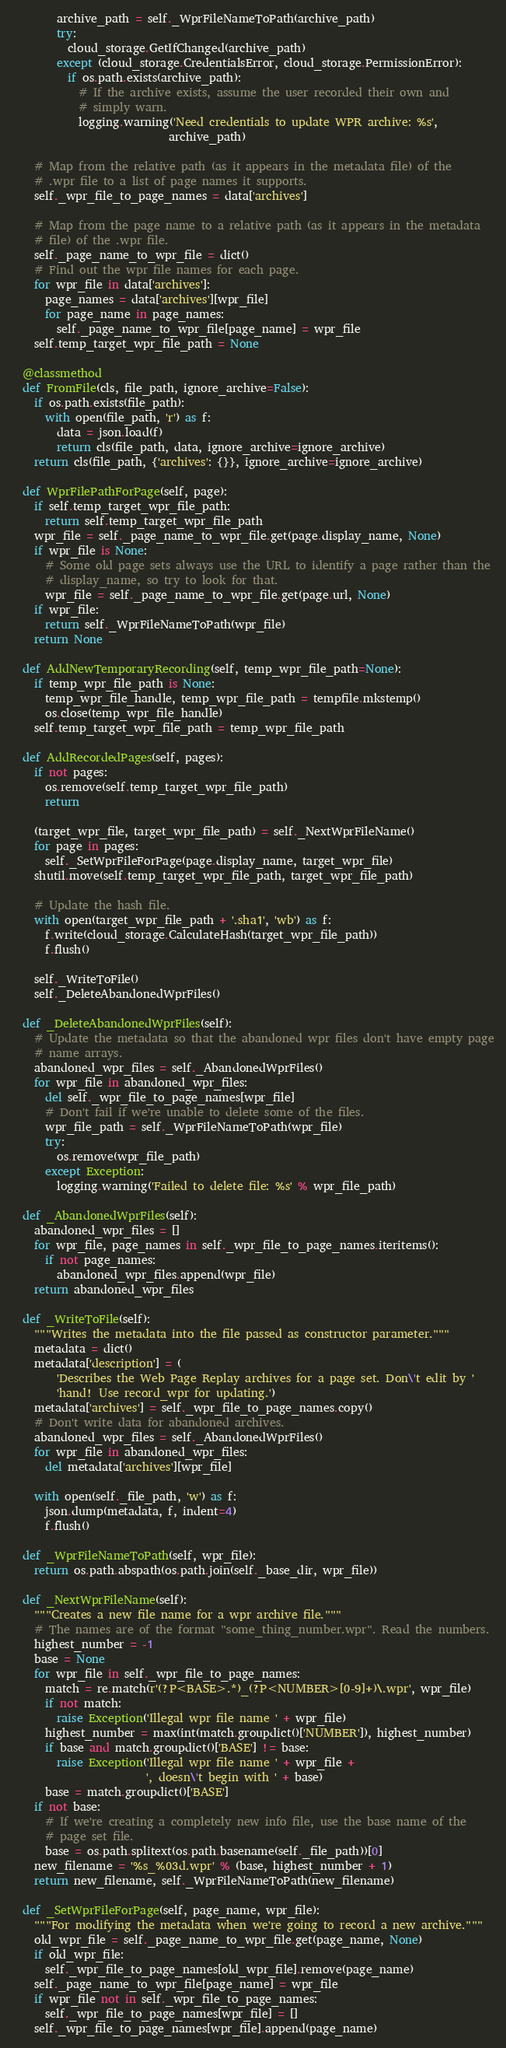<code> <loc_0><loc_0><loc_500><loc_500><_Python_>        archive_path = self._WprFileNameToPath(archive_path)
        try:
          cloud_storage.GetIfChanged(archive_path)
        except (cloud_storage.CredentialsError, cloud_storage.PermissionError):
          if os.path.exists(archive_path):
            # If the archive exists, assume the user recorded their own and
            # simply warn.
            logging.warning('Need credentials to update WPR archive: %s',
                            archive_path)

    # Map from the relative path (as it appears in the metadata file) of the
    # .wpr file to a list of page names it supports.
    self._wpr_file_to_page_names = data['archives']

    # Map from the page name to a relative path (as it appears in the metadata
    # file) of the .wpr file.
    self._page_name_to_wpr_file = dict()
    # Find out the wpr file names for each page.
    for wpr_file in data['archives']:
      page_names = data['archives'][wpr_file]
      for page_name in page_names:
        self._page_name_to_wpr_file[page_name] = wpr_file
    self.temp_target_wpr_file_path = None

  @classmethod
  def FromFile(cls, file_path, ignore_archive=False):
    if os.path.exists(file_path):
      with open(file_path, 'r') as f:
        data = json.load(f)
        return cls(file_path, data, ignore_archive=ignore_archive)
    return cls(file_path, {'archives': {}}, ignore_archive=ignore_archive)

  def WprFilePathForPage(self, page):
    if self.temp_target_wpr_file_path:
      return self.temp_target_wpr_file_path
    wpr_file = self._page_name_to_wpr_file.get(page.display_name, None)
    if wpr_file is None:
      # Some old page sets always use the URL to identify a page rather than the
      # display_name, so try to look for that.
      wpr_file = self._page_name_to_wpr_file.get(page.url, None)
    if wpr_file:
      return self._WprFileNameToPath(wpr_file)
    return None

  def AddNewTemporaryRecording(self, temp_wpr_file_path=None):
    if temp_wpr_file_path is None:
      temp_wpr_file_handle, temp_wpr_file_path = tempfile.mkstemp()
      os.close(temp_wpr_file_handle)
    self.temp_target_wpr_file_path = temp_wpr_file_path

  def AddRecordedPages(self, pages):
    if not pages:
      os.remove(self.temp_target_wpr_file_path)
      return

    (target_wpr_file, target_wpr_file_path) = self._NextWprFileName()
    for page in pages:
      self._SetWprFileForPage(page.display_name, target_wpr_file)
    shutil.move(self.temp_target_wpr_file_path, target_wpr_file_path)

    # Update the hash file.
    with open(target_wpr_file_path + '.sha1', 'wb') as f:
      f.write(cloud_storage.CalculateHash(target_wpr_file_path))
      f.flush()

    self._WriteToFile()
    self._DeleteAbandonedWprFiles()

  def _DeleteAbandonedWprFiles(self):
    # Update the metadata so that the abandoned wpr files don't have empty page
    # name arrays.
    abandoned_wpr_files = self._AbandonedWprFiles()
    for wpr_file in abandoned_wpr_files:
      del self._wpr_file_to_page_names[wpr_file]
      # Don't fail if we're unable to delete some of the files.
      wpr_file_path = self._WprFileNameToPath(wpr_file)
      try:
        os.remove(wpr_file_path)
      except Exception:
        logging.warning('Failed to delete file: %s' % wpr_file_path)

  def _AbandonedWprFiles(self):
    abandoned_wpr_files = []
    for wpr_file, page_names in self._wpr_file_to_page_names.iteritems():
      if not page_names:
        abandoned_wpr_files.append(wpr_file)
    return abandoned_wpr_files

  def _WriteToFile(self):
    """Writes the metadata into the file passed as constructor parameter."""
    metadata = dict()
    metadata['description'] = (
        'Describes the Web Page Replay archives for a page set. Don\'t edit by '
        'hand! Use record_wpr for updating.')
    metadata['archives'] = self._wpr_file_to_page_names.copy()
    # Don't write data for abandoned archives.
    abandoned_wpr_files = self._AbandonedWprFiles()
    for wpr_file in abandoned_wpr_files:
      del metadata['archives'][wpr_file]

    with open(self._file_path, 'w') as f:
      json.dump(metadata, f, indent=4)
      f.flush()

  def _WprFileNameToPath(self, wpr_file):
    return os.path.abspath(os.path.join(self._base_dir, wpr_file))

  def _NextWprFileName(self):
    """Creates a new file name for a wpr archive file."""
    # The names are of the format "some_thing_number.wpr". Read the numbers.
    highest_number = -1
    base = None
    for wpr_file in self._wpr_file_to_page_names:
      match = re.match(r'(?P<BASE>.*)_(?P<NUMBER>[0-9]+)\.wpr', wpr_file)
      if not match:
        raise Exception('Illegal wpr file name ' + wpr_file)
      highest_number = max(int(match.groupdict()['NUMBER']), highest_number)
      if base and match.groupdict()['BASE'] != base:
        raise Exception('Illegal wpr file name ' + wpr_file +
                        ', doesn\'t begin with ' + base)
      base = match.groupdict()['BASE']
    if not base:
      # If we're creating a completely new info file, use the base name of the
      # page set file.
      base = os.path.splitext(os.path.basename(self._file_path))[0]
    new_filename = '%s_%03d.wpr' % (base, highest_number + 1)
    return new_filename, self._WprFileNameToPath(new_filename)

  def _SetWprFileForPage(self, page_name, wpr_file):
    """For modifying the metadata when we're going to record a new archive."""
    old_wpr_file = self._page_name_to_wpr_file.get(page_name, None)
    if old_wpr_file:
      self._wpr_file_to_page_names[old_wpr_file].remove(page_name)
    self._page_name_to_wpr_file[page_name] = wpr_file
    if wpr_file not in self._wpr_file_to_page_names:
      self._wpr_file_to_page_names[wpr_file] = []
    self._wpr_file_to_page_names[wpr_file].append(page_name)
</code> 